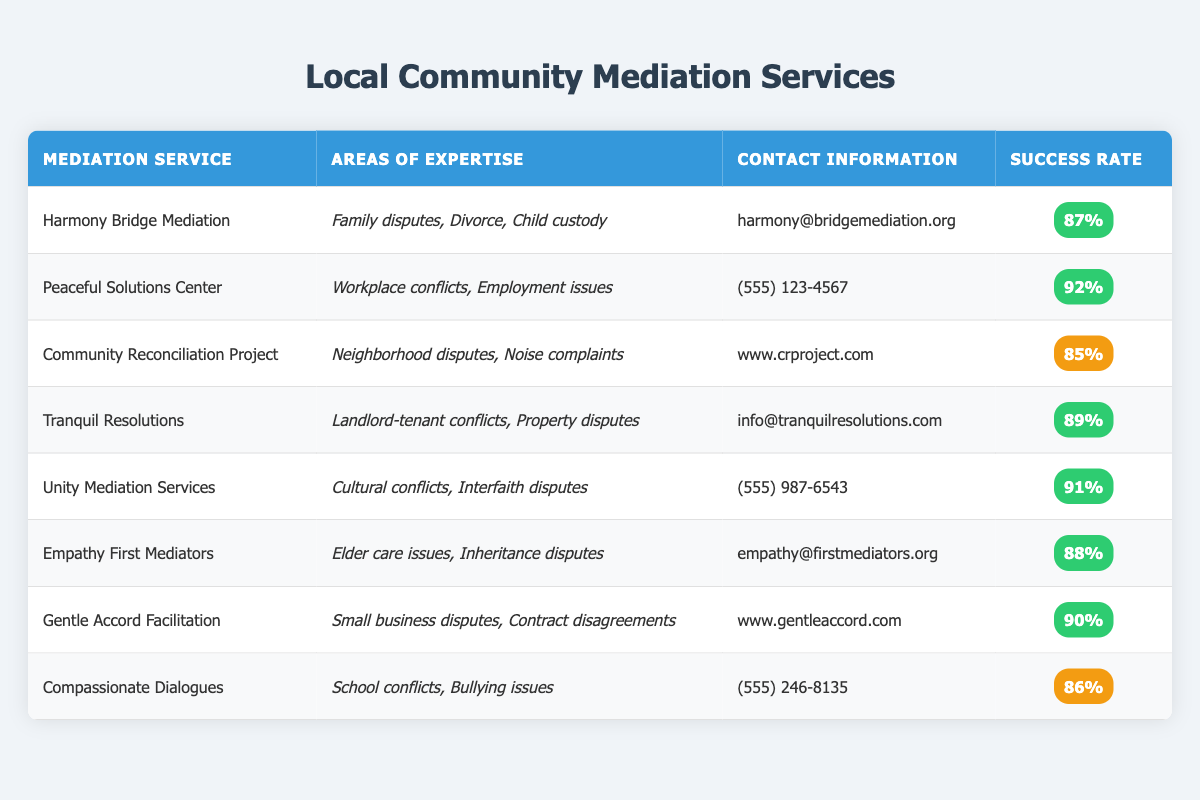What is the success rate of Peaceful Solutions Center? The success rate is listed in the last column for Peaceful Solutions Center, which shows 92%.
Answer: 92% Which mediation service specializes in landlord-tenant conflicts? Tranquil Resolutions is indicated in the table as specializing in landlord-tenant conflicts.
Answer: Tranquil Resolutions What is the average success rate of the mediation services listed? To find the average, we sum the success rates: 87 + 92 + 85 + 89 + 91 + 88 + 90 + 86 = 718. There are 8 services, so the average success rate is 718/8 = 89.75%.
Answer: 89.75% Does Community Reconciliation Project have a higher success rate than Empathy First Mediators? Community Reconciliation Project has a success rate of 85%, while Empathy First Mediators has 88%. Since 85% is less than 88%, the statement is false.
Answer: No Which service has expertise in cultural conflicts? Unity Mediation Services is the service listed with expertise in cultural conflicts.
Answer: Unity Mediation Services How many services have a success rate of 90% or higher? The services with a success rate of 90% or higher are: Peaceful Solutions Center (92%), Unity Mediation Services (91%), Gentle Accord Facilitation (90%). This makes a total of 3 services with a success rate of 90% or above.
Answer: 3 Is there a service that specializes in school conflicts? Yes, Compassionate Dialogues specializes in school conflicts as noted in the areas of expertise column.
Answer: Yes Which mediation service has the lowest success rate? By comparing the success rates, Compassionate Dialogues has the lowest success rate at 86%.
Answer: Compassionate Dialogues 